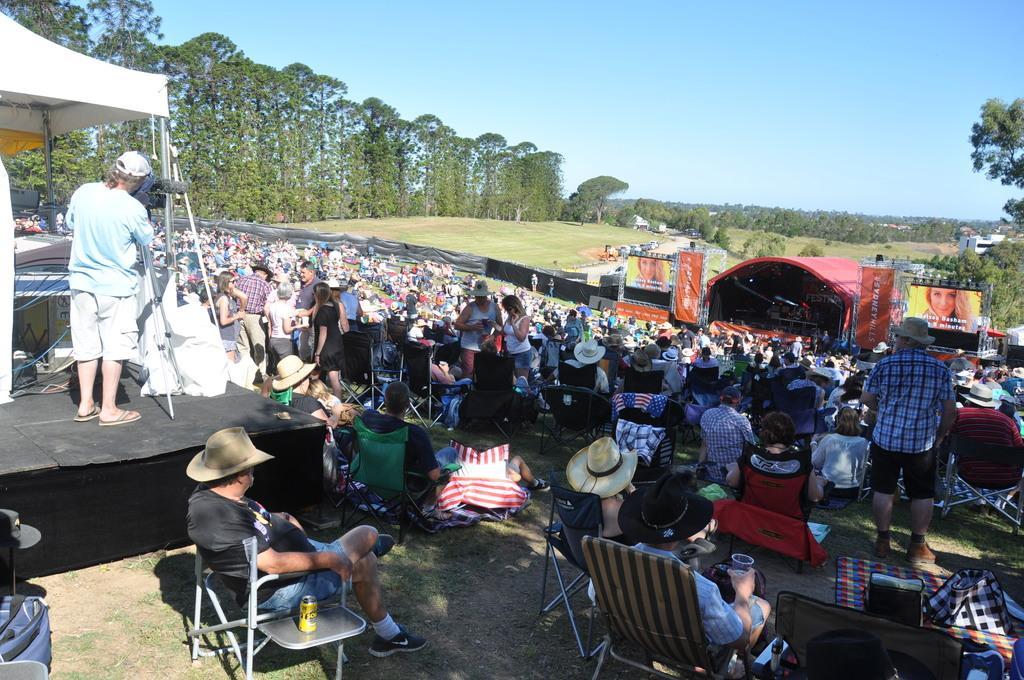Describe this image in one or two sentences. Here some people are sitting on the chairs and some people are standing, these are trees and a sky. 